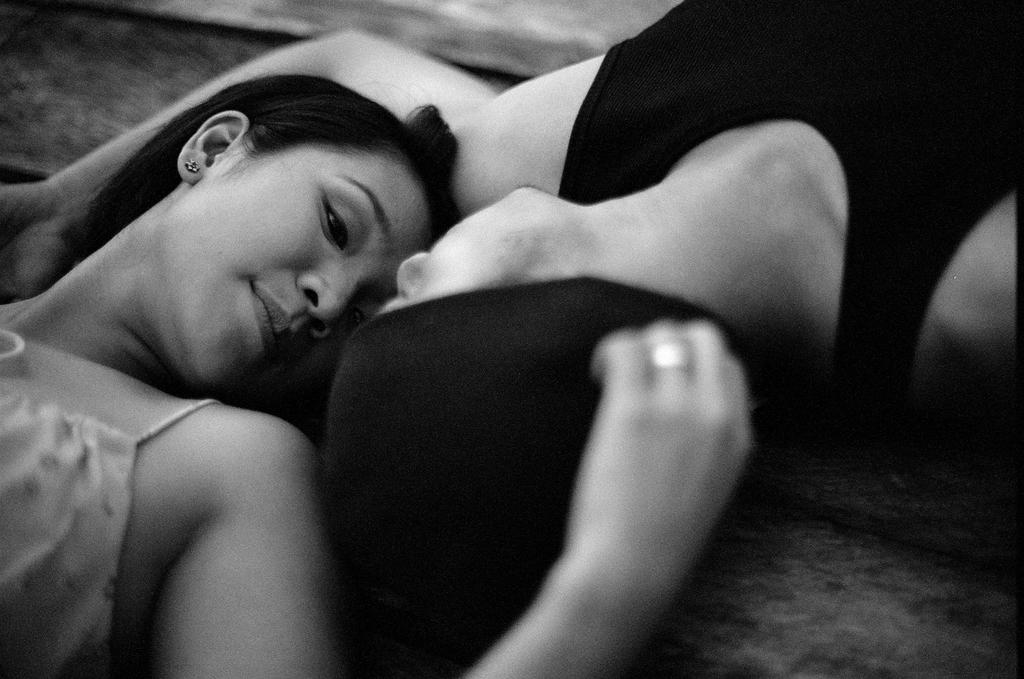What are the two people in the image doing? Both the man and the woman are lying on a surface in the foreground. What is the color scheme of the image? The image is in black and white. Can you see any spots on the man's thumb in the image? There is no mention of spots or thumbs in the provided facts, and therefore it cannot be determined if any spots are visible on the man's thumb in the image. 